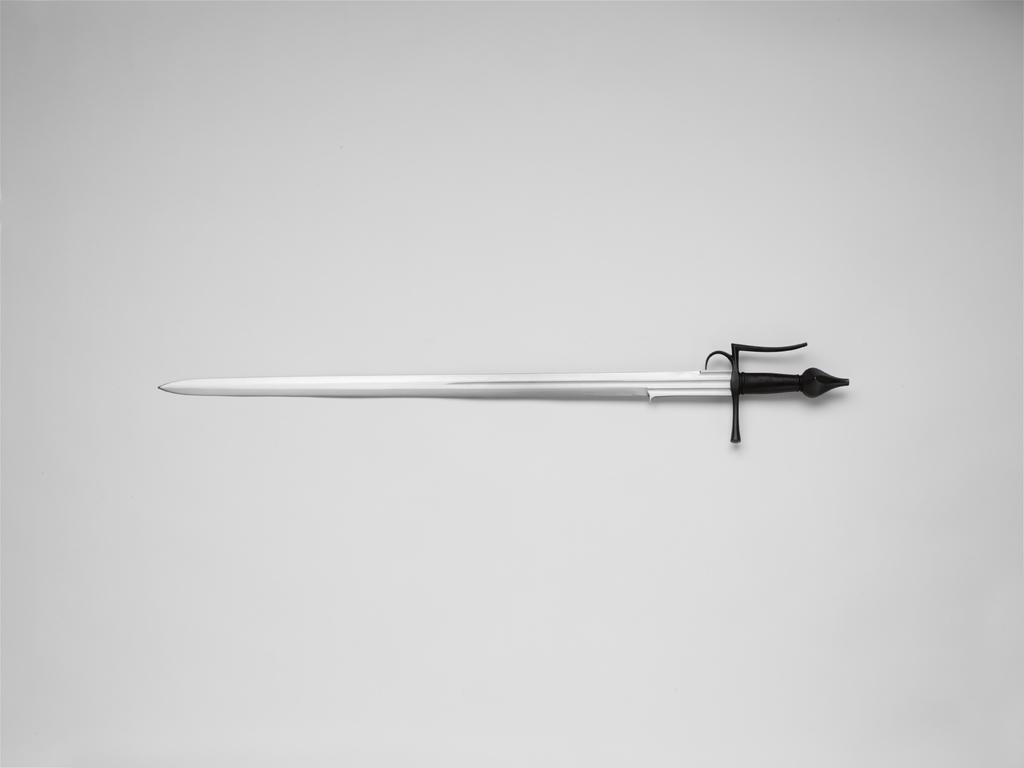What object is located in the middle of the image? There is a sword in the middle of the image. What color is the background of the image? The background of the image is white. What language is spoken by the sword in the image? The sword is an inanimate object and cannot speak any language. 